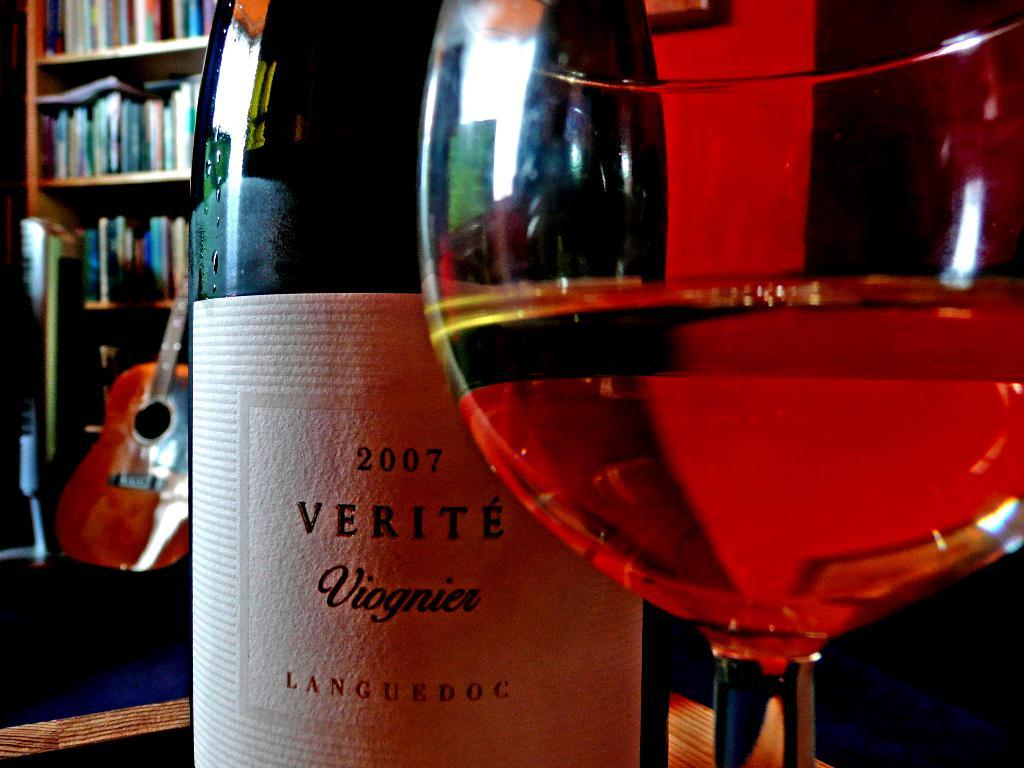<image>
Offer a succinct explanation of the picture presented. A bottle of wine with the label 2007 VERITE Viognier. 